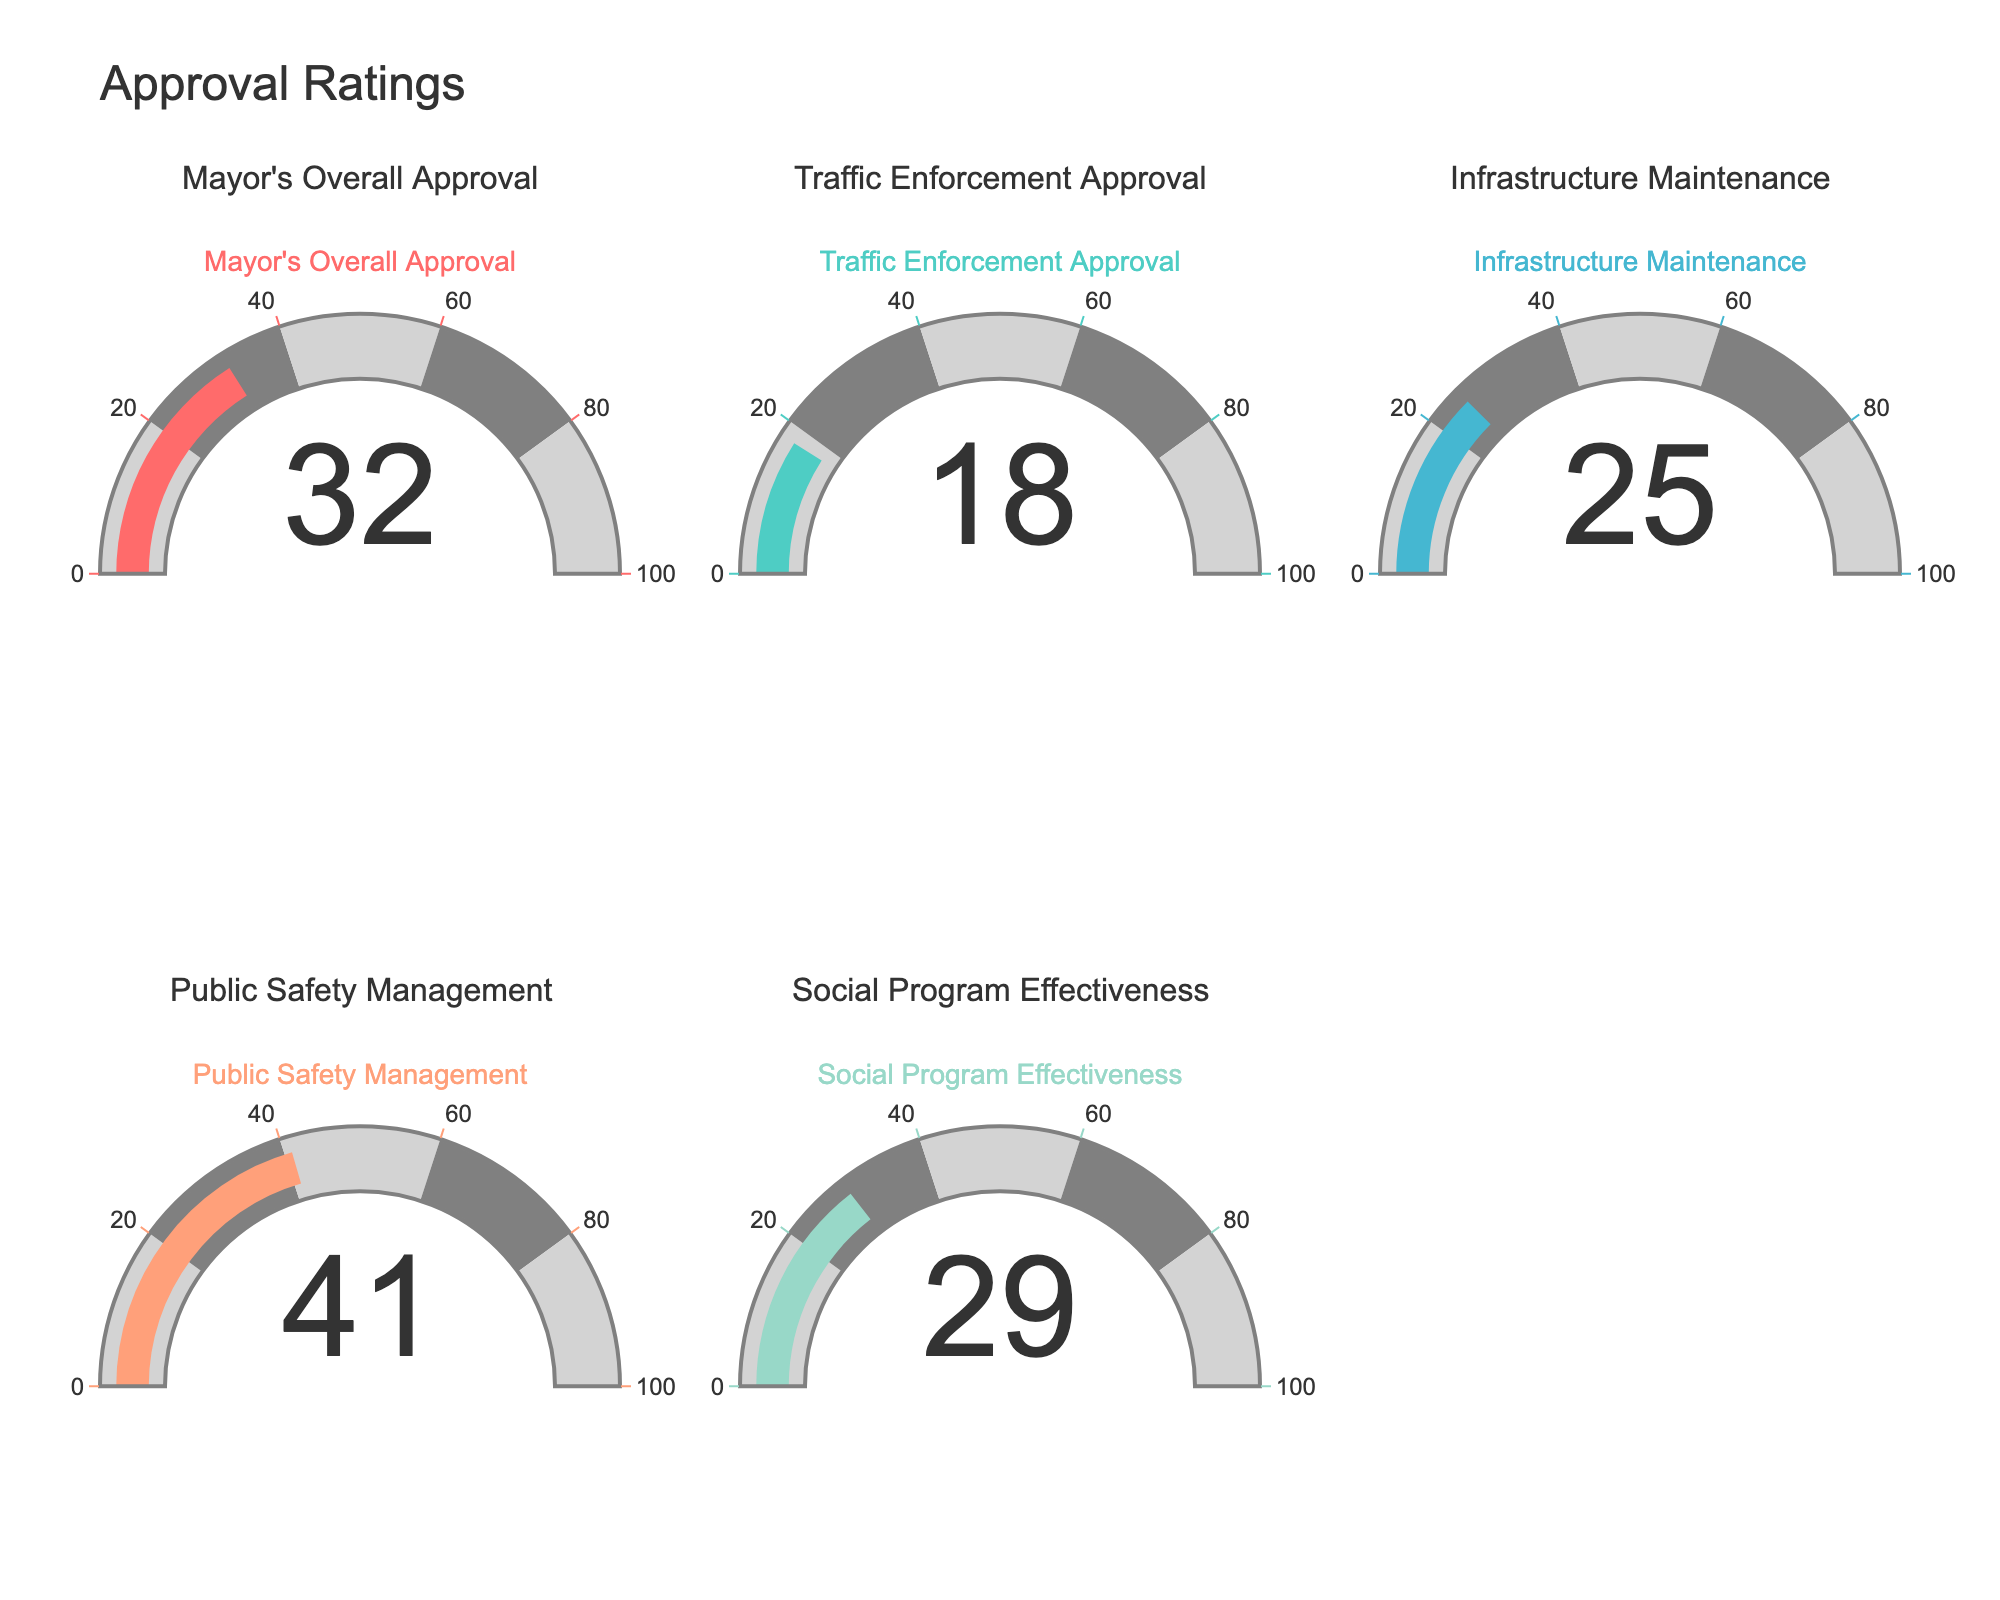What is the title of the figure? The title of the figure is shown at the top and reads "Approval Ratings."
Answer: Approval Ratings What is the approval rating for Traffic Enforcement? The approval rating for Traffic Enforcement is displayed within its respective gauge, which is one of the subplots.
Answer: 18 Which category has the highest approval rating? The Public Safety Management gauge shows the highest value among all categories.
Answer: Public Safety Management What is the average approval rating across all categories? The approval ratings are 32, 18, 25, 41, and 29. Sum these values to get 145, then divide by 5 to get the average. 145/5 = 29.
Answer: 29 How much higher is the Public Safety Management approval rating compared to Infrastructure Maintenance? The approval rating for Public Safety Management is 41, and for Infrastructure Maintenance, it is 25. The difference is calculated as 41 - 25 = 16.
Answer: 16 Which category has the lowest approval rating? The Traffic Enforcement gauge displays the lowest value among all categories.
Answer: Traffic Enforcement What is the combined approval rating for Mayor's Overall Approval and Social Program Effectiveness? The Mayor's Overall Approval rating is 32 and Social Program Effectiveness is 29. Sum these values to get 61.
Answer: 61 Is the approval rating for Infrastructure Maintenance above 20? The gauge for Infrastructure Maintenance indicates a value of 25, which is above 20.
Answer: Yes Which approval rating is closest to the median of all the ratings? Sorting the approval ratings (18, 25, 29, 32, 41), the median value is 29, which is the approval rating for Social Program Effectiveness.
Answer: Social Program Effectiveness 